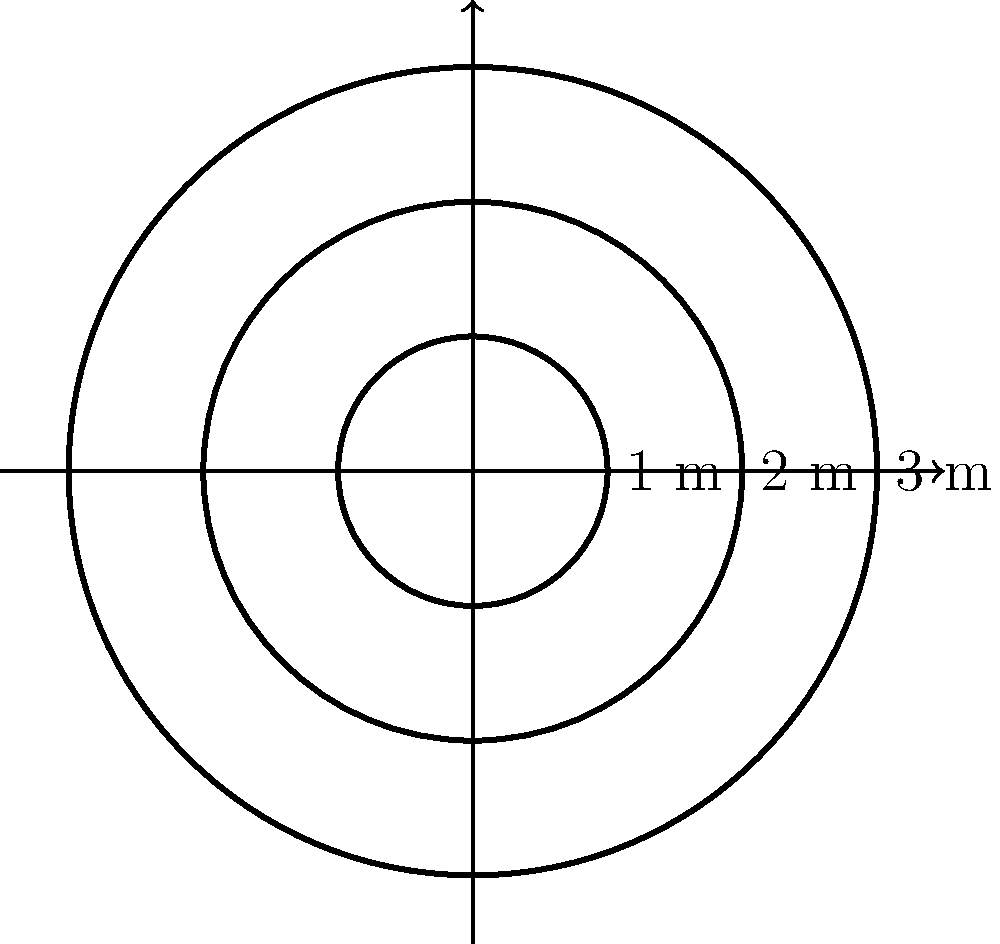As an aspiring archer, you're practicing with a target that consists of three concentric circles. The outermost circle has a radius of 3 meters, the middle circle has a radius of 2 meters, and the innermost circle has a radius of 1 meter. What is the total perimeter of all three circles combined? (Use $\pi = 3.14$ for your calculations) Let's approach this step-by-step:

1) The formula for the circumference (perimeter) of a circle is $C = 2\pi r$, where $r$ is the radius.

2) For the outermost circle:
   $C_1 = 2\pi(3) = 6\pi$ meters

3) For the middle circle:
   $C_2 = 2\pi(2) = 4\pi$ meters

4) For the innermost circle:
   $C_3 = 2\pi(1) = 2\pi$ meters

5) The total perimeter is the sum of all three circumferences:
   $C_{total} = C_1 + C_2 + C_3 = 6\pi + 4\pi + 2\pi = 12\pi$ meters

6) Now, let's substitute $\pi = 3.14$:
   $C_{total} = 12(3.14) = 37.68$ meters

Therefore, the total perimeter of all three circles combined is 37.68 meters.
Answer: 37.68 meters 